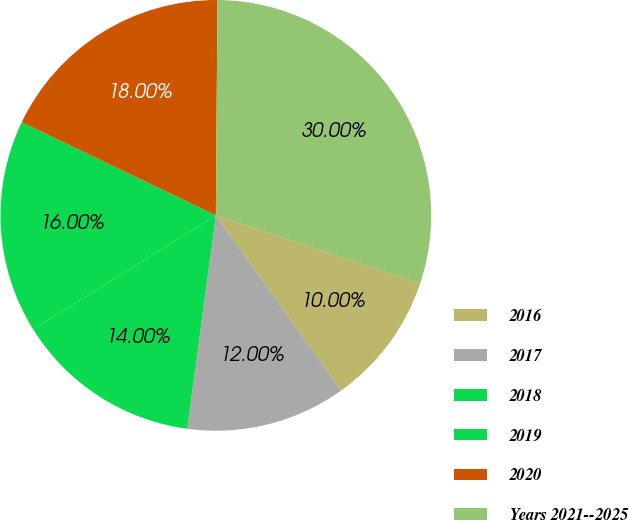Convert chart to OTSL. <chart><loc_0><loc_0><loc_500><loc_500><pie_chart><fcel>2016<fcel>2017<fcel>2018<fcel>2019<fcel>2020<fcel>Years 2021-­2025<nl><fcel>10.0%<fcel>12.0%<fcel>14.0%<fcel>16.0%<fcel>18.0%<fcel>30.0%<nl></chart> 